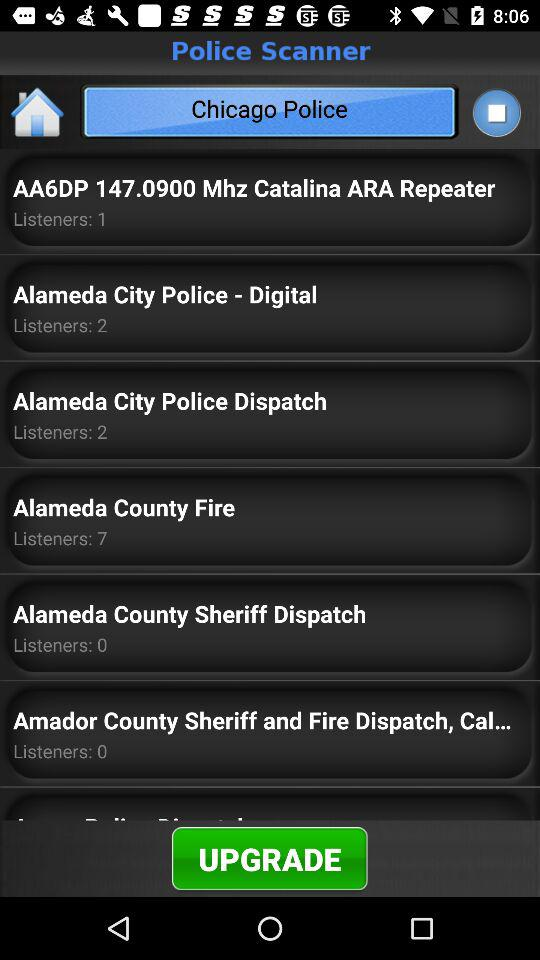What's the number of listeners to "Alameda City Police Dispatch"? The number of listeners is 2. 